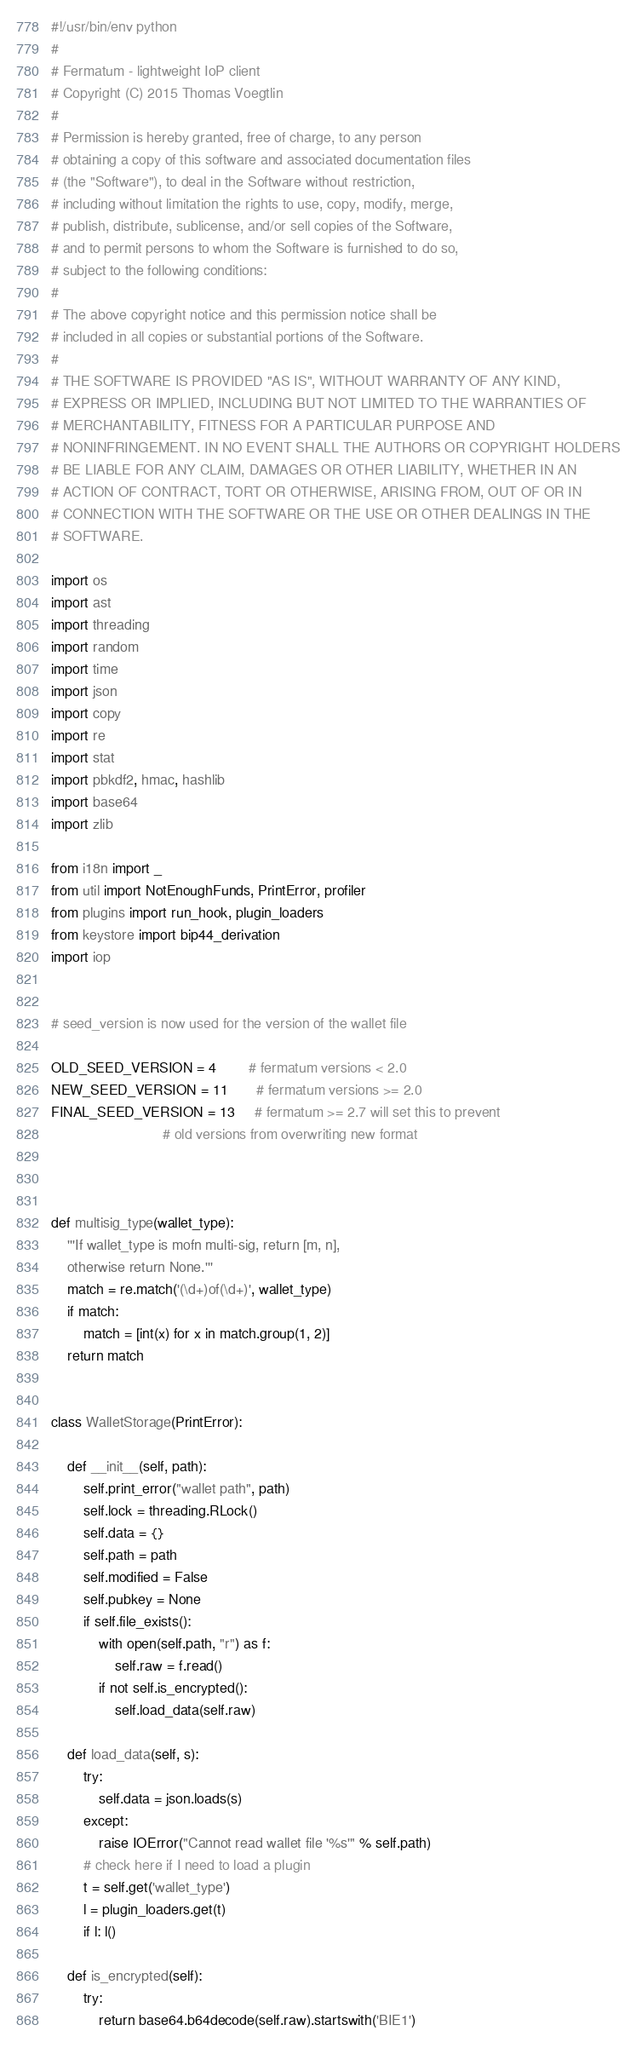Convert code to text. <code><loc_0><loc_0><loc_500><loc_500><_Python_>#!/usr/bin/env python
#
# Fermatum - lightweight IoP client
# Copyright (C) 2015 Thomas Voegtlin
#
# Permission is hereby granted, free of charge, to any person
# obtaining a copy of this software and associated documentation files
# (the "Software"), to deal in the Software without restriction,
# including without limitation the rights to use, copy, modify, merge,
# publish, distribute, sublicense, and/or sell copies of the Software,
# and to permit persons to whom the Software is furnished to do so,
# subject to the following conditions:
#
# The above copyright notice and this permission notice shall be
# included in all copies or substantial portions of the Software.
#
# THE SOFTWARE IS PROVIDED "AS IS", WITHOUT WARRANTY OF ANY KIND,
# EXPRESS OR IMPLIED, INCLUDING BUT NOT LIMITED TO THE WARRANTIES OF
# MERCHANTABILITY, FITNESS FOR A PARTICULAR PURPOSE AND
# NONINFRINGEMENT. IN NO EVENT SHALL THE AUTHORS OR COPYRIGHT HOLDERS
# BE LIABLE FOR ANY CLAIM, DAMAGES OR OTHER LIABILITY, WHETHER IN AN
# ACTION OF CONTRACT, TORT OR OTHERWISE, ARISING FROM, OUT OF OR IN
# CONNECTION WITH THE SOFTWARE OR THE USE OR OTHER DEALINGS IN THE
# SOFTWARE.

import os
import ast
import threading
import random
import time
import json
import copy
import re
import stat
import pbkdf2, hmac, hashlib
import base64
import zlib

from i18n import _
from util import NotEnoughFunds, PrintError, profiler
from plugins import run_hook, plugin_loaders
from keystore import bip44_derivation
import iop


# seed_version is now used for the version of the wallet file

OLD_SEED_VERSION = 4        # fermatum versions < 2.0
NEW_SEED_VERSION = 11       # fermatum versions >= 2.0
FINAL_SEED_VERSION = 13     # fermatum >= 2.7 will set this to prevent
                            # old versions from overwriting new format



def multisig_type(wallet_type):
    '''If wallet_type is mofn multi-sig, return [m, n],
    otherwise return None.'''
    match = re.match('(\d+)of(\d+)', wallet_type)
    if match:
        match = [int(x) for x in match.group(1, 2)]
    return match


class WalletStorage(PrintError):

    def __init__(self, path):
        self.print_error("wallet path", path)
        self.lock = threading.RLock()
        self.data = {}
        self.path = path
        self.modified = False
        self.pubkey = None
        if self.file_exists():
            with open(self.path, "r") as f:
                self.raw = f.read()
            if not self.is_encrypted():
                self.load_data(self.raw)

    def load_data(self, s):
        try:
            self.data = json.loads(s)
        except:
            raise IOError("Cannot read wallet file '%s'" % self.path)
        # check here if I need to load a plugin
        t = self.get('wallet_type')
        l = plugin_loaders.get(t)
        if l: l()

    def is_encrypted(self):
        try:
            return base64.b64decode(self.raw).startswith('BIE1')</code> 